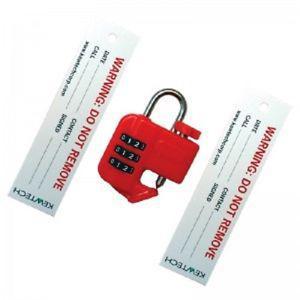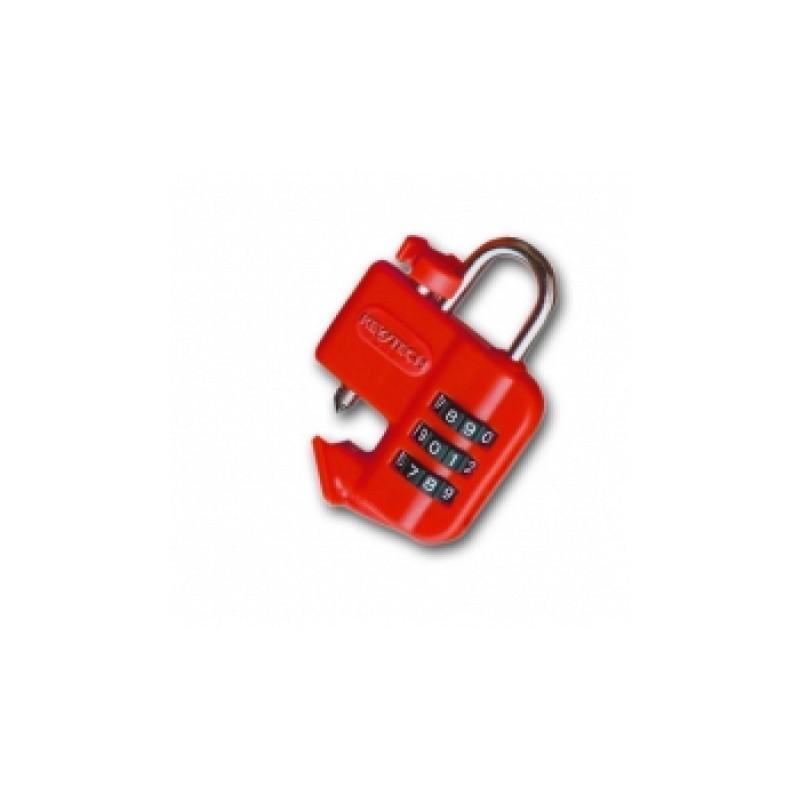The first image is the image on the left, the second image is the image on the right. Examine the images to the left and right. Is the description "There are two warning tags with a red lock." accurate? Answer yes or no. Yes. 